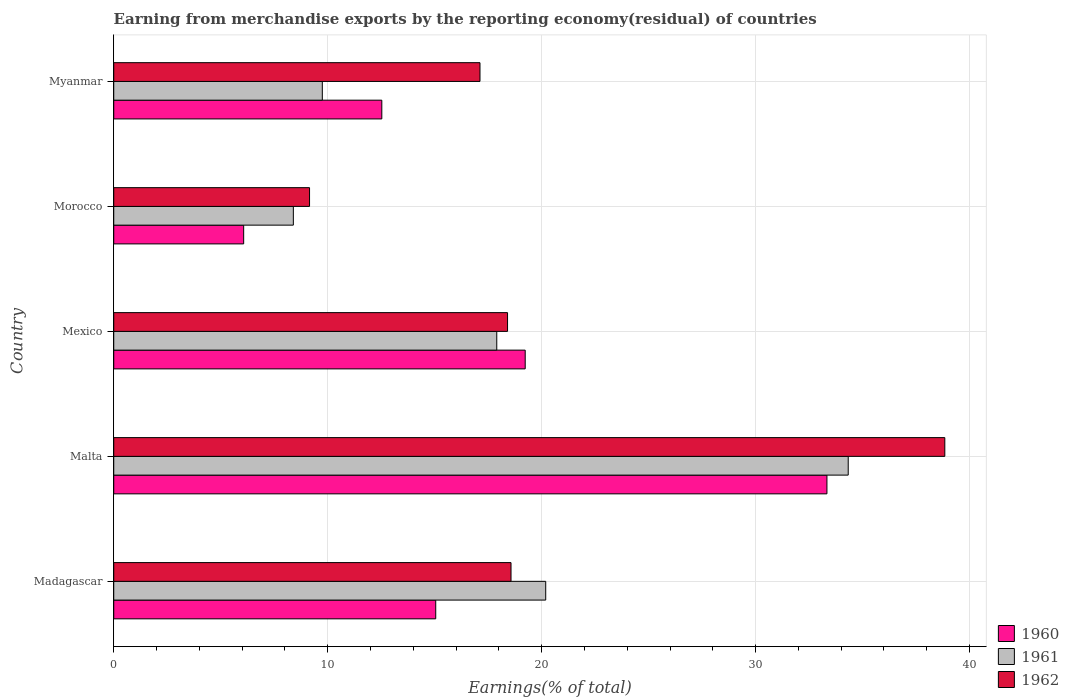How many bars are there on the 5th tick from the top?
Give a very brief answer. 3. How many bars are there on the 1st tick from the bottom?
Give a very brief answer. 3. What is the label of the 2nd group of bars from the top?
Keep it short and to the point. Morocco. In how many cases, is the number of bars for a given country not equal to the number of legend labels?
Your answer should be very brief. 0. What is the percentage of amount earned from merchandise exports in 1961 in Malta?
Keep it short and to the point. 34.33. Across all countries, what is the maximum percentage of amount earned from merchandise exports in 1962?
Offer a terse response. 38.84. Across all countries, what is the minimum percentage of amount earned from merchandise exports in 1960?
Provide a short and direct response. 6.07. In which country was the percentage of amount earned from merchandise exports in 1961 maximum?
Make the answer very short. Malta. In which country was the percentage of amount earned from merchandise exports in 1960 minimum?
Ensure brevity in your answer.  Morocco. What is the total percentage of amount earned from merchandise exports in 1962 in the graph?
Your response must be concise. 102.09. What is the difference between the percentage of amount earned from merchandise exports in 1961 in Morocco and that in Myanmar?
Make the answer very short. -1.35. What is the difference between the percentage of amount earned from merchandise exports in 1960 in Malta and the percentage of amount earned from merchandise exports in 1961 in Morocco?
Ensure brevity in your answer.  24.94. What is the average percentage of amount earned from merchandise exports in 1962 per country?
Provide a short and direct response. 20.42. What is the difference between the percentage of amount earned from merchandise exports in 1961 and percentage of amount earned from merchandise exports in 1962 in Morocco?
Offer a very short reply. -0.76. What is the ratio of the percentage of amount earned from merchandise exports in 1960 in Madagascar to that in Morocco?
Offer a terse response. 2.48. Is the percentage of amount earned from merchandise exports in 1960 in Malta less than that in Myanmar?
Keep it short and to the point. No. What is the difference between the highest and the second highest percentage of amount earned from merchandise exports in 1960?
Your answer should be very brief. 14.1. What is the difference between the highest and the lowest percentage of amount earned from merchandise exports in 1960?
Provide a succinct answer. 27.26. What does the 2nd bar from the top in Malta represents?
Keep it short and to the point. 1961. Is it the case that in every country, the sum of the percentage of amount earned from merchandise exports in 1960 and percentage of amount earned from merchandise exports in 1962 is greater than the percentage of amount earned from merchandise exports in 1961?
Ensure brevity in your answer.  Yes. Are all the bars in the graph horizontal?
Give a very brief answer. Yes. How many countries are there in the graph?
Make the answer very short. 5. Are the values on the major ticks of X-axis written in scientific E-notation?
Ensure brevity in your answer.  No. Does the graph contain any zero values?
Provide a succinct answer. No. How many legend labels are there?
Offer a terse response. 3. What is the title of the graph?
Your answer should be compact. Earning from merchandise exports by the reporting economy(residual) of countries. Does "1983" appear as one of the legend labels in the graph?
Give a very brief answer. No. What is the label or title of the X-axis?
Give a very brief answer. Earnings(% of total). What is the label or title of the Y-axis?
Provide a succinct answer. Country. What is the Earnings(% of total) of 1960 in Madagascar?
Offer a very short reply. 15.05. What is the Earnings(% of total) in 1961 in Madagascar?
Make the answer very short. 20.19. What is the Earnings(% of total) of 1962 in Madagascar?
Make the answer very short. 18.57. What is the Earnings(% of total) of 1960 in Malta?
Your response must be concise. 33.33. What is the Earnings(% of total) in 1961 in Malta?
Make the answer very short. 34.33. What is the Earnings(% of total) of 1962 in Malta?
Give a very brief answer. 38.84. What is the Earnings(% of total) in 1960 in Mexico?
Provide a short and direct response. 19.23. What is the Earnings(% of total) of 1961 in Mexico?
Ensure brevity in your answer.  17.9. What is the Earnings(% of total) in 1962 in Mexico?
Provide a short and direct response. 18.41. What is the Earnings(% of total) in 1960 in Morocco?
Your answer should be compact. 6.07. What is the Earnings(% of total) in 1961 in Morocco?
Give a very brief answer. 8.39. What is the Earnings(% of total) of 1962 in Morocco?
Your answer should be compact. 9.15. What is the Earnings(% of total) in 1960 in Myanmar?
Keep it short and to the point. 12.53. What is the Earnings(% of total) in 1961 in Myanmar?
Provide a succinct answer. 9.75. What is the Earnings(% of total) of 1962 in Myanmar?
Your answer should be compact. 17.12. Across all countries, what is the maximum Earnings(% of total) of 1960?
Ensure brevity in your answer.  33.33. Across all countries, what is the maximum Earnings(% of total) in 1961?
Your answer should be very brief. 34.33. Across all countries, what is the maximum Earnings(% of total) in 1962?
Your answer should be very brief. 38.84. Across all countries, what is the minimum Earnings(% of total) in 1960?
Offer a terse response. 6.07. Across all countries, what is the minimum Earnings(% of total) in 1961?
Provide a succinct answer. 8.39. Across all countries, what is the minimum Earnings(% of total) of 1962?
Ensure brevity in your answer.  9.15. What is the total Earnings(% of total) of 1960 in the graph?
Your response must be concise. 86.22. What is the total Earnings(% of total) of 1961 in the graph?
Offer a very short reply. 90.56. What is the total Earnings(% of total) of 1962 in the graph?
Make the answer very short. 102.09. What is the difference between the Earnings(% of total) in 1960 in Madagascar and that in Malta?
Your response must be concise. -18.28. What is the difference between the Earnings(% of total) in 1961 in Madagascar and that in Malta?
Your answer should be very brief. -14.14. What is the difference between the Earnings(% of total) of 1962 in Madagascar and that in Malta?
Your answer should be compact. -20.27. What is the difference between the Earnings(% of total) in 1960 in Madagascar and that in Mexico?
Offer a very short reply. -4.18. What is the difference between the Earnings(% of total) in 1961 in Madagascar and that in Mexico?
Make the answer very short. 2.29. What is the difference between the Earnings(% of total) in 1962 in Madagascar and that in Mexico?
Your answer should be very brief. 0.16. What is the difference between the Earnings(% of total) of 1960 in Madagascar and that in Morocco?
Your answer should be compact. 8.98. What is the difference between the Earnings(% of total) of 1961 in Madagascar and that in Morocco?
Your response must be concise. 11.8. What is the difference between the Earnings(% of total) in 1962 in Madagascar and that in Morocco?
Offer a very short reply. 9.42. What is the difference between the Earnings(% of total) of 1960 in Madagascar and that in Myanmar?
Give a very brief answer. 2.52. What is the difference between the Earnings(% of total) in 1961 in Madagascar and that in Myanmar?
Keep it short and to the point. 10.44. What is the difference between the Earnings(% of total) in 1962 in Madagascar and that in Myanmar?
Offer a terse response. 1.45. What is the difference between the Earnings(% of total) of 1960 in Malta and that in Mexico?
Make the answer very short. 14.1. What is the difference between the Earnings(% of total) of 1961 in Malta and that in Mexico?
Provide a succinct answer. 16.43. What is the difference between the Earnings(% of total) in 1962 in Malta and that in Mexico?
Give a very brief answer. 20.44. What is the difference between the Earnings(% of total) in 1960 in Malta and that in Morocco?
Your answer should be compact. 27.26. What is the difference between the Earnings(% of total) of 1961 in Malta and that in Morocco?
Provide a short and direct response. 25.93. What is the difference between the Earnings(% of total) of 1962 in Malta and that in Morocco?
Your response must be concise. 29.69. What is the difference between the Earnings(% of total) of 1960 in Malta and that in Myanmar?
Ensure brevity in your answer.  20.8. What is the difference between the Earnings(% of total) in 1961 in Malta and that in Myanmar?
Offer a terse response. 24.58. What is the difference between the Earnings(% of total) of 1962 in Malta and that in Myanmar?
Your answer should be compact. 21.73. What is the difference between the Earnings(% of total) of 1960 in Mexico and that in Morocco?
Make the answer very short. 13.16. What is the difference between the Earnings(% of total) of 1961 in Mexico and that in Morocco?
Make the answer very short. 9.51. What is the difference between the Earnings(% of total) in 1962 in Mexico and that in Morocco?
Your response must be concise. 9.25. What is the difference between the Earnings(% of total) of 1960 in Mexico and that in Myanmar?
Provide a succinct answer. 6.7. What is the difference between the Earnings(% of total) in 1961 in Mexico and that in Myanmar?
Make the answer very short. 8.15. What is the difference between the Earnings(% of total) of 1962 in Mexico and that in Myanmar?
Your response must be concise. 1.29. What is the difference between the Earnings(% of total) of 1960 in Morocco and that in Myanmar?
Offer a very short reply. -6.46. What is the difference between the Earnings(% of total) of 1961 in Morocco and that in Myanmar?
Ensure brevity in your answer.  -1.35. What is the difference between the Earnings(% of total) in 1962 in Morocco and that in Myanmar?
Ensure brevity in your answer.  -7.97. What is the difference between the Earnings(% of total) in 1960 in Madagascar and the Earnings(% of total) in 1961 in Malta?
Your response must be concise. -19.28. What is the difference between the Earnings(% of total) in 1960 in Madagascar and the Earnings(% of total) in 1962 in Malta?
Your answer should be compact. -23.79. What is the difference between the Earnings(% of total) of 1961 in Madagascar and the Earnings(% of total) of 1962 in Malta?
Offer a very short reply. -18.65. What is the difference between the Earnings(% of total) of 1960 in Madagascar and the Earnings(% of total) of 1961 in Mexico?
Give a very brief answer. -2.85. What is the difference between the Earnings(% of total) in 1960 in Madagascar and the Earnings(% of total) in 1962 in Mexico?
Provide a succinct answer. -3.36. What is the difference between the Earnings(% of total) in 1961 in Madagascar and the Earnings(% of total) in 1962 in Mexico?
Your answer should be very brief. 1.78. What is the difference between the Earnings(% of total) of 1960 in Madagascar and the Earnings(% of total) of 1961 in Morocco?
Offer a very short reply. 6.66. What is the difference between the Earnings(% of total) in 1960 in Madagascar and the Earnings(% of total) in 1962 in Morocco?
Provide a short and direct response. 5.9. What is the difference between the Earnings(% of total) in 1961 in Madagascar and the Earnings(% of total) in 1962 in Morocco?
Offer a terse response. 11.04. What is the difference between the Earnings(% of total) of 1960 in Madagascar and the Earnings(% of total) of 1961 in Myanmar?
Offer a terse response. 5.3. What is the difference between the Earnings(% of total) in 1960 in Madagascar and the Earnings(% of total) in 1962 in Myanmar?
Provide a short and direct response. -2.07. What is the difference between the Earnings(% of total) in 1961 in Madagascar and the Earnings(% of total) in 1962 in Myanmar?
Provide a succinct answer. 3.07. What is the difference between the Earnings(% of total) in 1960 in Malta and the Earnings(% of total) in 1961 in Mexico?
Your answer should be very brief. 15.43. What is the difference between the Earnings(% of total) of 1960 in Malta and the Earnings(% of total) of 1962 in Mexico?
Your answer should be very brief. 14.93. What is the difference between the Earnings(% of total) of 1961 in Malta and the Earnings(% of total) of 1962 in Mexico?
Your answer should be very brief. 15.92. What is the difference between the Earnings(% of total) of 1960 in Malta and the Earnings(% of total) of 1961 in Morocco?
Ensure brevity in your answer.  24.94. What is the difference between the Earnings(% of total) of 1960 in Malta and the Earnings(% of total) of 1962 in Morocco?
Your answer should be compact. 24.18. What is the difference between the Earnings(% of total) in 1961 in Malta and the Earnings(% of total) in 1962 in Morocco?
Make the answer very short. 25.18. What is the difference between the Earnings(% of total) of 1960 in Malta and the Earnings(% of total) of 1961 in Myanmar?
Provide a succinct answer. 23.59. What is the difference between the Earnings(% of total) of 1960 in Malta and the Earnings(% of total) of 1962 in Myanmar?
Provide a short and direct response. 16.22. What is the difference between the Earnings(% of total) in 1961 in Malta and the Earnings(% of total) in 1962 in Myanmar?
Ensure brevity in your answer.  17.21. What is the difference between the Earnings(% of total) in 1960 in Mexico and the Earnings(% of total) in 1961 in Morocco?
Your answer should be very brief. 10.84. What is the difference between the Earnings(% of total) in 1960 in Mexico and the Earnings(% of total) in 1962 in Morocco?
Ensure brevity in your answer.  10.08. What is the difference between the Earnings(% of total) in 1961 in Mexico and the Earnings(% of total) in 1962 in Morocco?
Provide a short and direct response. 8.75. What is the difference between the Earnings(% of total) of 1960 in Mexico and the Earnings(% of total) of 1961 in Myanmar?
Offer a very short reply. 9.48. What is the difference between the Earnings(% of total) of 1960 in Mexico and the Earnings(% of total) of 1962 in Myanmar?
Your answer should be compact. 2.11. What is the difference between the Earnings(% of total) in 1961 in Mexico and the Earnings(% of total) in 1962 in Myanmar?
Your answer should be very brief. 0.78. What is the difference between the Earnings(% of total) of 1960 in Morocco and the Earnings(% of total) of 1961 in Myanmar?
Keep it short and to the point. -3.68. What is the difference between the Earnings(% of total) in 1960 in Morocco and the Earnings(% of total) in 1962 in Myanmar?
Provide a succinct answer. -11.05. What is the difference between the Earnings(% of total) in 1961 in Morocco and the Earnings(% of total) in 1962 in Myanmar?
Offer a very short reply. -8.72. What is the average Earnings(% of total) in 1960 per country?
Offer a very short reply. 17.24. What is the average Earnings(% of total) of 1961 per country?
Keep it short and to the point. 18.11. What is the average Earnings(% of total) of 1962 per country?
Your answer should be very brief. 20.42. What is the difference between the Earnings(% of total) in 1960 and Earnings(% of total) in 1961 in Madagascar?
Offer a terse response. -5.14. What is the difference between the Earnings(% of total) of 1960 and Earnings(% of total) of 1962 in Madagascar?
Ensure brevity in your answer.  -3.52. What is the difference between the Earnings(% of total) of 1961 and Earnings(% of total) of 1962 in Madagascar?
Ensure brevity in your answer.  1.62. What is the difference between the Earnings(% of total) of 1960 and Earnings(% of total) of 1961 in Malta?
Your answer should be compact. -0.99. What is the difference between the Earnings(% of total) in 1960 and Earnings(% of total) in 1962 in Malta?
Keep it short and to the point. -5.51. What is the difference between the Earnings(% of total) in 1961 and Earnings(% of total) in 1962 in Malta?
Ensure brevity in your answer.  -4.51. What is the difference between the Earnings(% of total) in 1960 and Earnings(% of total) in 1961 in Mexico?
Make the answer very short. 1.33. What is the difference between the Earnings(% of total) in 1960 and Earnings(% of total) in 1962 in Mexico?
Your answer should be very brief. 0.83. What is the difference between the Earnings(% of total) in 1961 and Earnings(% of total) in 1962 in Mexico?
Provide a succinct answer. -0.5. What is the difference between the Earnings(% of total) of 1960 and Earnings(% of total) of 1961 in Morocco?
Provide a succinct answer. -2.32. What is the difference between the Earnings(% of total) in 1960 and Earnings(% of total) in 1962 in Morocco?
Make the answer very short. -3.08. What is the difference between the Earnings(% of total) in 1961 and Earnings(% of total) in 1962 in Morocco?
Keep it short and to the point. -0.76. What is the difference between the Earnings(% of total) of 1960 and Earnings(% of total) of 1961 in Myanmar?
Your response must be concise. 2.78. What is the difference between the Earnings(% of total) of 1960 and Earnings(% of total) of 1962 in Myanmar?
Give a very brief answer. -4.59. What is the difference between the Earnings(% of total) of 1961 and Earnings(% of total) of 1962 in Myanmar?
Offer a terse response. -7.37. What is the ratio of the Earnings(% of total) of 1960 in Madagascar to that in Malta?
Your response must be concise. 0.45. What is the ratio of the Earnings(% of total) of 1961 in Madagascar to that in Malta?
Make the answer very short. 0.59. What is the ratio of the Earnings(% of total) in 1962 in Madagascar to that in Malta?
Offer a terse response. 0.48. What is the ratio of the Earnings(% of total) of 1960 in Madagascar to that in Mexico?
Your response must be concise. 0.78. What is the ratio of the Earnings(% of total) of 1961 in Madagascar to that in Mexico?
Offer a very short reply. 1.13. What is the ratio of the Earnings(% of total) in 1962 in Madagascar to that in Mexico?
Your answer should be compact. 1.01. What is the ratio of the Earnings(% of total) in 1960 in Madagascar to that in Morocco?
Make the answer very short. 2.48. What is the ratio of the Earnings(% of total) of 1961 in Madagascar to that in Morocco?
Provide a short and direct response. 2.41. What is the ratio of the Earnings(% of total) of 1962 in Madagascar to that in Morocco?
Your answer should be compact. 2.03. What is the ratio of the Earnings(% of total) of 1960 in Madagascar to that in Myanmar?
Give a very brief answer. 1.2. What is the ratio of the Earnings(% of total) in 1961 in Madagascar to that in Myanmar?
Make the answer very short. 2.07. What is the ratio of the Earnings(% of total) of 1962 in Madagascar to that in Myanmar?
Your response must be concise. 1.08. What is the ratio of the Earnings(% of total) of 1960 in Malta to that in Mexico?
Keep it short and to the point. 1.73. What is the ratio of the Earnings(% of total) in 1961 in Malta to that in Mexico?
Your answer should be compact. 1.92. What is the ratio of the Earnings(% of total) in 1962 in Malta to that in Mexico?
Offer a very short reply. 2.11. What is the ratio of the Earnings(% of total) in 1960 in Malta to that in Morocco?
Ensure brevity in your answer.  5.49. What is the ratio of the Earnings(% of total) of 1961 in Malta to that in Morocco?
Ensure brevity in your answer.  4.09. What is the ratio of the Earnings(% of total) in 1962 in Malta to that in Morocco?
Provide a succinct answer. 4.24. What is the ratio of the Earnings(% of total) of 1960 in Malta to that in Myanmar?
Your response must be concise. 2.66. What is the ratio of the Earnings(% of total) in 1961 in Malta to that in Myanmar?
Offer a very short reply. 3.52. What is the ratio of the Earnings(% of total) in 1962 in Malta to that in Myanmar?
Provide a succinct answer. 2.27. What is the ratio of the Earnings(% of total) of 1960 in Mexico to that in Morocco?
Offer a terse response. 3.17. What is the ratio of the Earnings(% of total) of 1961 in Mexico to that in Morocco?
Provide a short and direct response. 2.13. What is the ratio of the Earnings(% of total) in 1962 in Mexico to that in Morocco?
Your response must be concise. 2.01. What is the ratio of the Earnings(% of total) of 1960 in Mexico to that in Myanmar?
Make the answer very short. 1.53. What is the ratio of the Earnings(% of total) in 1961 in Mexico to that in Myanmar?
Offer a terse response. 1.84. What is the ratio of the Earnings(% of total) of 1962 in Mexico to that in Myanmar?
Give a very brief answer. 1.08. What is the ratio of the Earnings(% of total) in 1960 in Morocco to that in Myanmar?
Your answer should be very brief. 0.48. What is the ratio of the Earnings(% of total) in 1961 in Morocco to that in Myanmar?
Provide a succinct answer. 0.86. What is the ratio of the Earnings(% of total) of 1962 in Morocco to that in Myanmar?
Keep it short and to the point. 0.53. What is the difference between the highest and the second highest Earnings(% of total) in 1960?
Offer a very short reply. 14.1. What is the difference between the highest and the second highest Earnings(% of total) of 1961?
Your answer should be very brief. 14.14. What is the difference between the highest and the second highest Earnings(% of total) in 1962?
Your response must be concise. 20.27. What is the difference between the highest and the lowest Earnings(% of total) of 1960?
Your response must be concise. 27.26. What is the difference between the highest and the lowest Earnings(% of total) in 1961?
Your response must be concise. 25.93. What is the difference between the highest and the lowest Earnings(% of total) of 1962?
Your answer should be very brief. 29.69. 